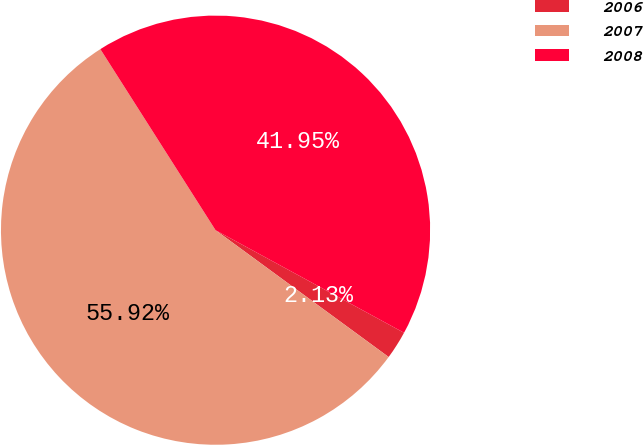Convert chart to OTSL. <chart><loc_0><loc_0><loc_500><loc_500><pie_chart><fcel>2006<fcel>2007<fcel>2008<nl><fcel>2.13%<fcel>55.91%<fcel>41.95%<nl></chart> 